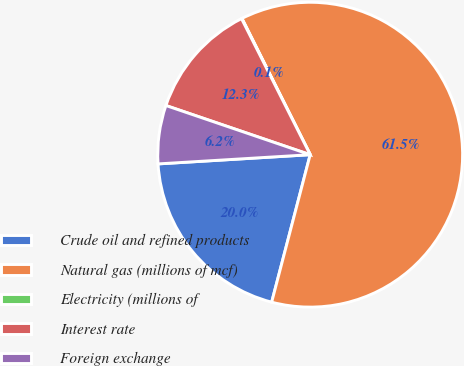Convert chart to OTSL. <chart><loc_0><loc_0><loc_500><loc_500><pie_chart><fcel>Crude oil and refined products<fcel>Natural gas (millions of mcf)<fcel>Electricity (millions of<fcel>Interest rate<fcel>Foreign exchange<nl><fcel>19.97%<fcel>61.45%<fcel>0.05%<fcel>12.33%<fcel>6.19%<nl></chart> 